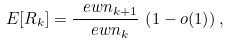Convert formula to latex. <formula><loc_0><loc_0><loc_500><loc_500>E [ R _ { k } ] = \frac { \ e w { n _ { k + 1 } } } { \ e w { n _ { k } } } \, \left ( 1 - o ( 1 ) \right ) ,</formula> 